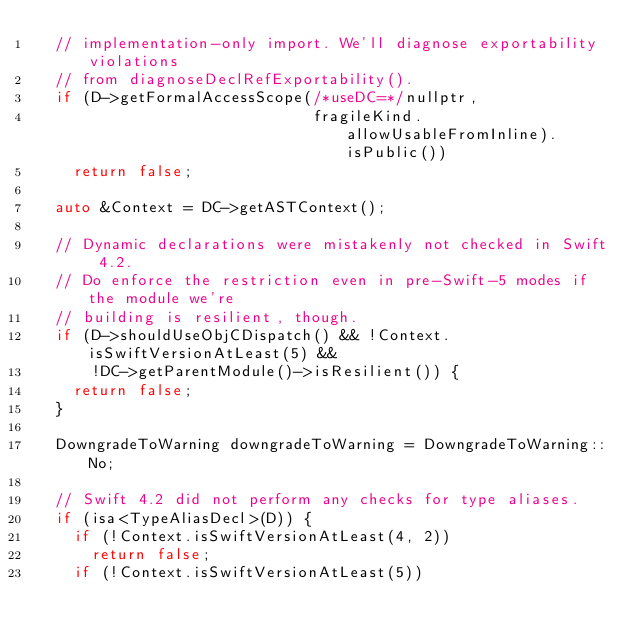<code> <loc_0><loc_0><loc_500><loc_500><_C++_>  // implementation-only import. We'll diagnose exportability violations
  // from diagnoseDeclRefExportability().
  if (D->getFormalAccessScope(/*useDC=*/nullptr,
                              fragileKind.allowUsableFromInline).isPublic())
    return false;

  auto &Context = DC->getASTContext();

  // Dynamic declarations were mistakenly not checked in Swift 4.2.
  // Do enforce the restriction even in pre-Swift-5 modes if the module we're
  // building is resilient, though.
  if (D->shouldUseObjCDispatch() && !Context.isSwiftVersionAtLeast(5) &&
      !DC->getParentModule()->isResilient()) {
    return false;
  }

  DowngradeToWarning downgradeToWarning = DowngradeToWarning::No;

  // Swift 4.2 did not perform any checks for type aliases.
  if (isa<TypeAliasDecl>(D)) {
    if (!Context.isSwiftVersionAtLeast(4, 2))
      return false;
    if (!Context.isSwiftVersionAtLeast(5))</code> 